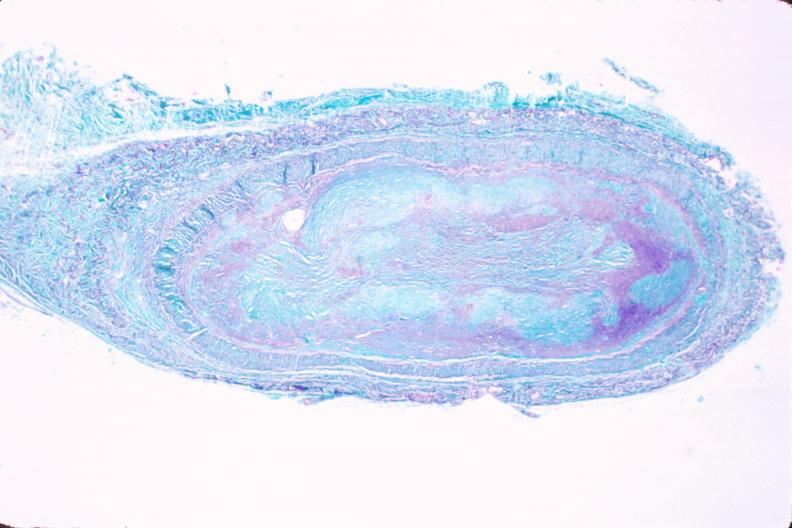s vasculature present?
Answer the question using a single word or phrase. Yes 